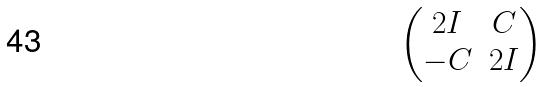Convert formula to latex. <formula><loc_0><loc_0><loc_500><loc_500>\begin{pmatrix} 2 I & C \\ - C & 2 I \end{pmatrix}</formula> 